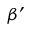Convert formula to latex. <formula><loc_0><loc_0><loc_500><loc_500>\beta ^ { \prime }</formula> 